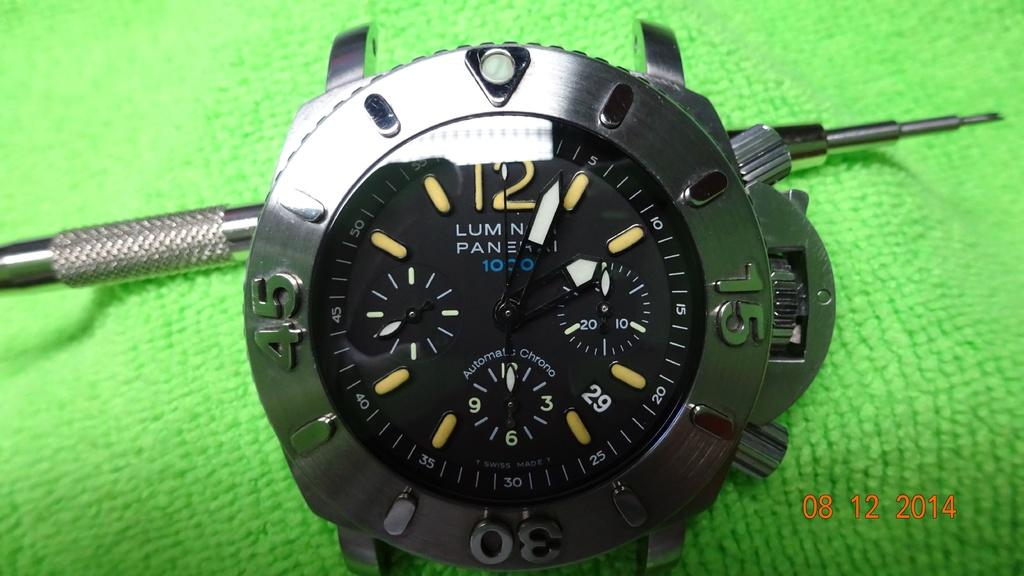<image>
Write a terse but informative summary of the picture. A watch with a 29 on the face, indicating the date, sits on a green cloth. 